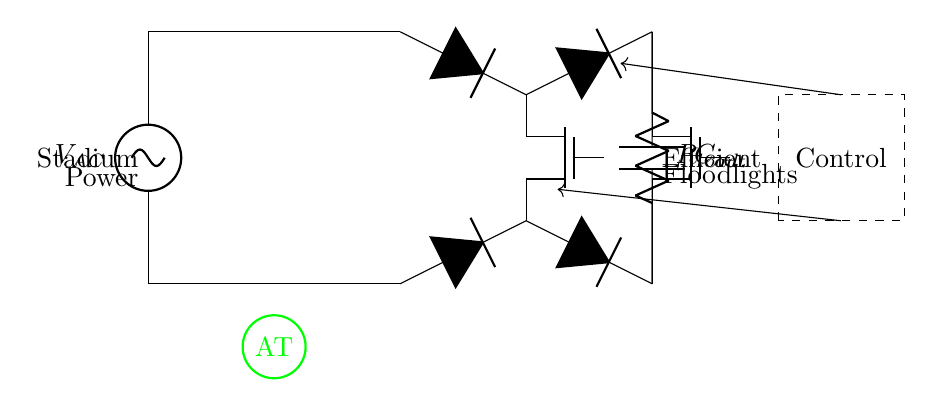What type of rectifier is shown in this circuit? The circuit features a synchronous rectifier, which utilizes MOSFETs instead of diodes for rectification, enhancing efficiency.
Answer: synchronous rectifier How many MOSFETs are present in the circuit? There are two MOSFETs labeled M1 and M2 in the circuit, connected in a bridge configuration.
Answer: 2 What is the purpose of the output capacitor in this circuit? The output capacitor smooths the rectified voltage, reducing ripple and providing a stable DC output for the floodlights.
Answer: smoothing Which component is responsible for current transformation in the circuit? The transformer is responsible for stepping up or stepping down the voltage while maintaining power balance, enabling suitable voltage levels for the load.
Answer: transformer What is the load connected to the output of the rectifier? There is a resistor labeled R_load, which represents the load that the floodlights will use, converting electrical energy into light.
Answer: R_load Why are synchronous MOSFETs used instead of diodes? Synchronous MOSFETs have lower on-resistance compared to diodes, which reduces conduction losses and improves overall efficiency in power conversion for floodlights.
Answer: efficiency What does the control circuit do in this configuration? The control circuit regulates the gate signals for the MOSFETs, ensuring they operate effectively, optimizing the rectification and enhancing system performance.
Answer: regulates gate signals 